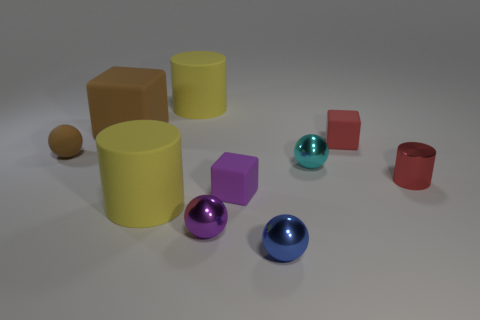What different colors can you identify in this image? The image features a rich palette with various colors: red, purple, blue, green, yellow, silver, and a brown that appears on different shaped objects. Each color aids in distinguishing the different geometrical shapes within the scene. Which object colors are repeated and how many times? The repeated colors in the image include yellow present in the two cylinders, and red found in the taller and shorter cylinders. The other colors like purple, blue, green, and brown appear uniquely on single objects. 